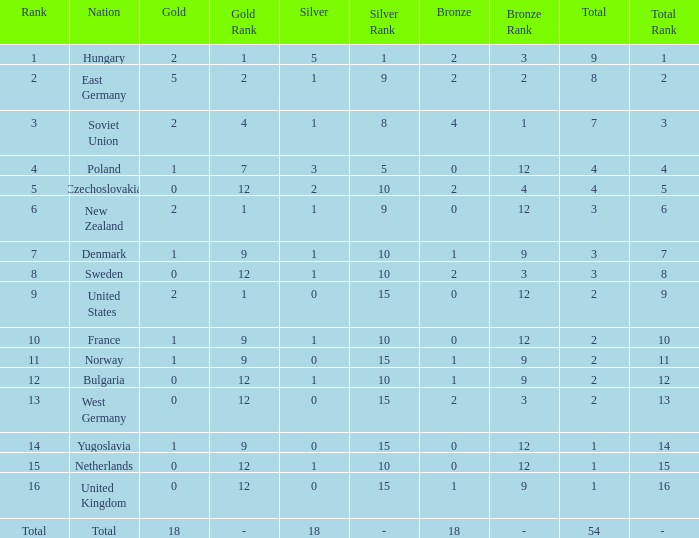What is the lowest total for those receiving less than 18 but more than 14? 1.0. 